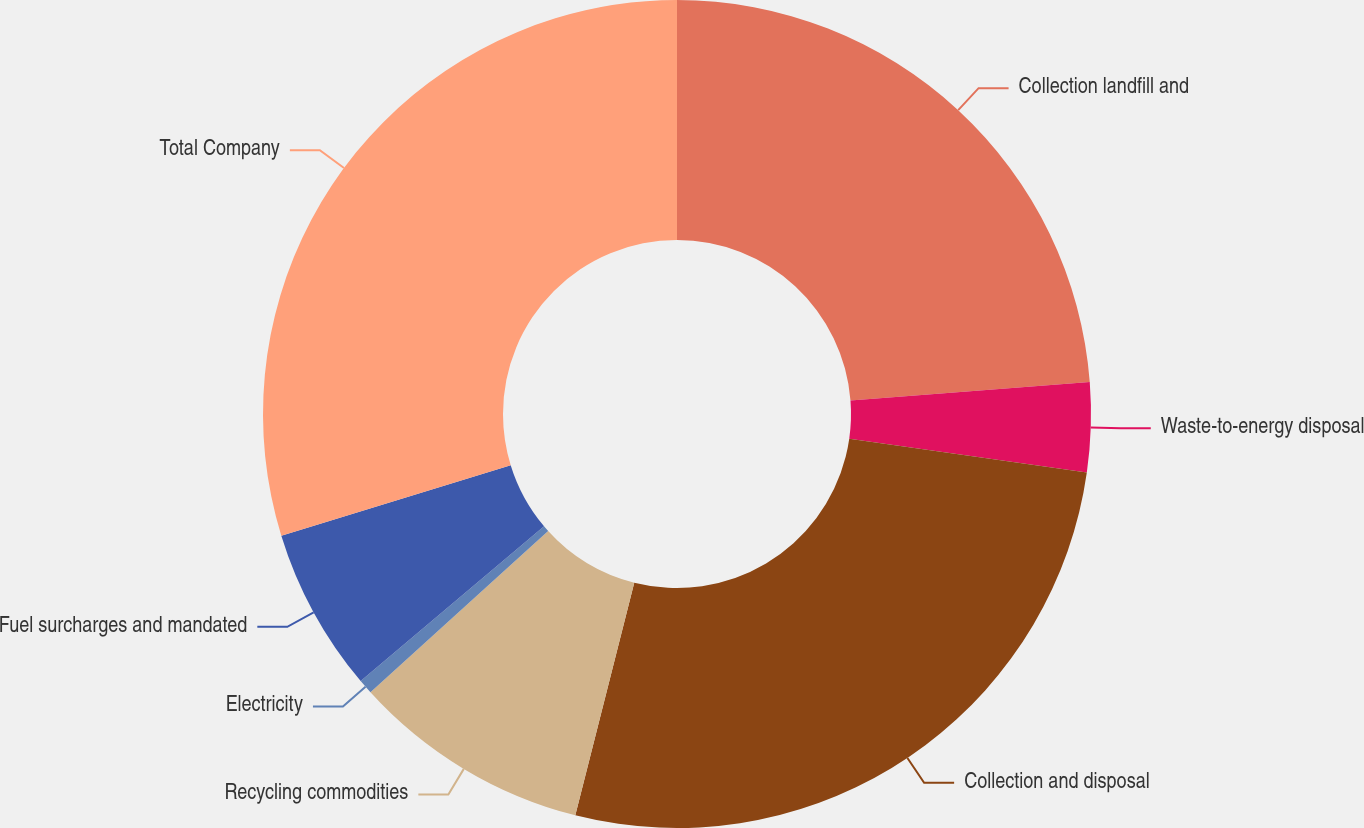Convert chart. <chart><loc_0><loc_0><loc_500><loc_500><pie_chart><fcel>Collection landfill and<fcel>Waste-to-energy disposal<fcel>Collection and disposal<fcel>Recycling commodities<fcel>Electricity<fcel>Fuel surcharges and mandated<fcel>Total Company<nl><fcel>23.77%<fcel>3.49%<fcel>26.69%<fcel>9.32%<fcel>0.57%<fcel>6.41%<fcel>29.75%<nl></chart> 